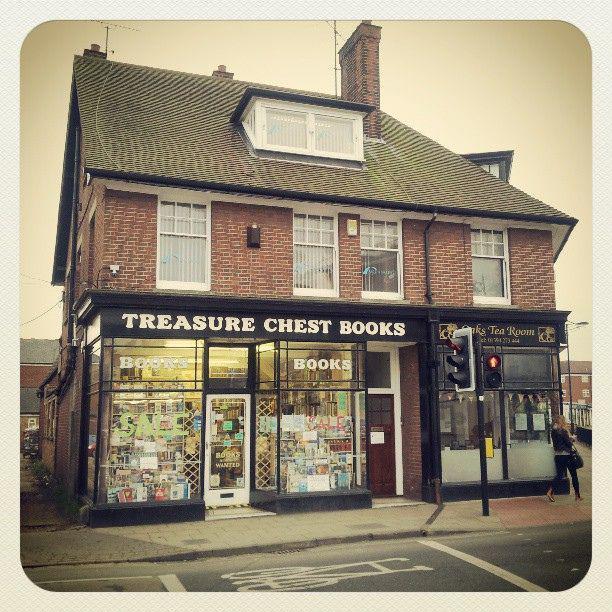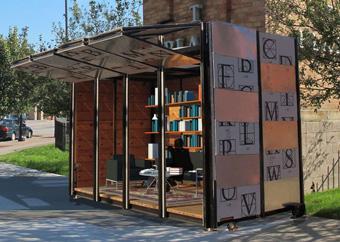The first image is the image on the left, the second image is the image on the right. Considering the images on both sides, is "A form of seating is shown outside of a bookstore." valid? Answer yes or no. No. The first image is the image on the left, the second image is the image on the right. For the images displayed, is the sentence "The exterior of a book shop includes some type of outdoor seating furniture." factually correct? Answer yes or no. No. 